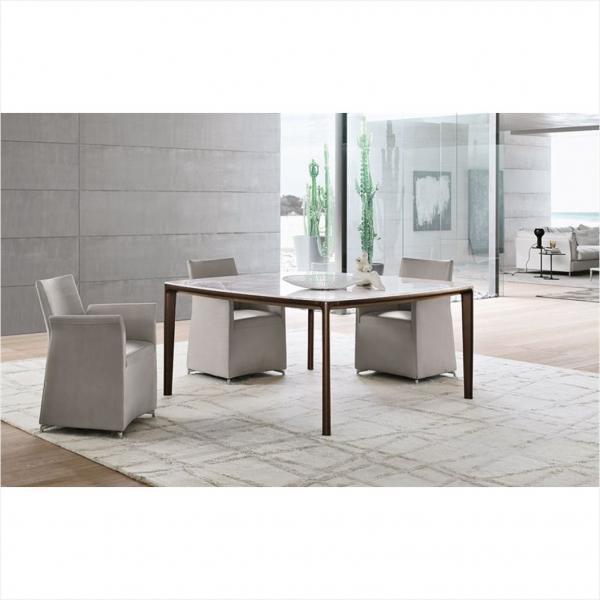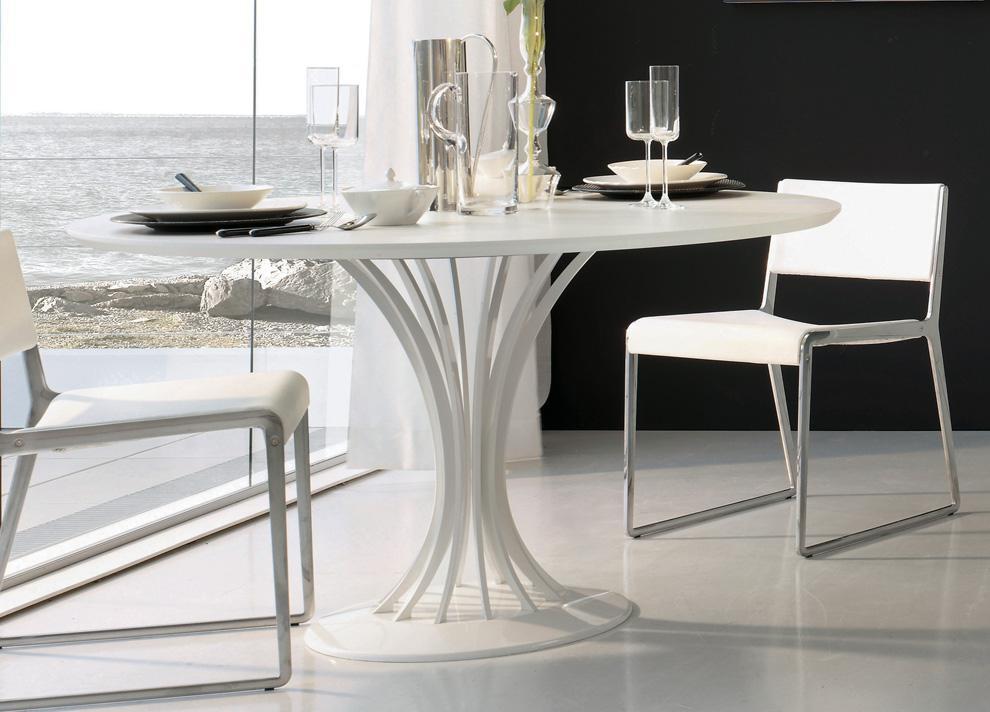The first image is the image on the left, the second image is the image on the right. For the images shown, is this caption "In one image, three armchairs are positioned by a square table." true? Answer yes or no. Yes. 